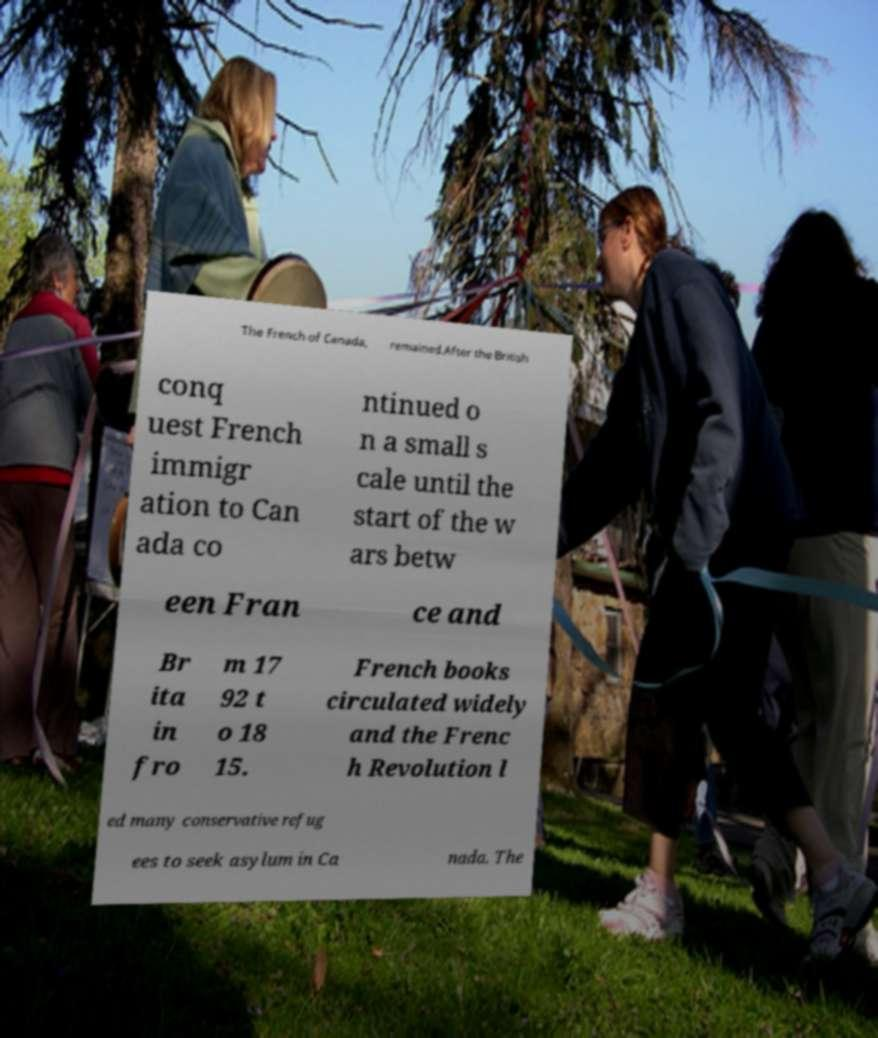Could you extract and type out the text from this image? The French of Canada, remained.After the British conq uest French immigr ation to Can ada co ntinued o n a small s cale until the start of the w ars betw een Fran ce and Br ita in fro m 17 92 t o 18 15. French books circulated widely and the Frenc h Revolution l ed many conservative refug ees to seek asylum in Ca nada. The 